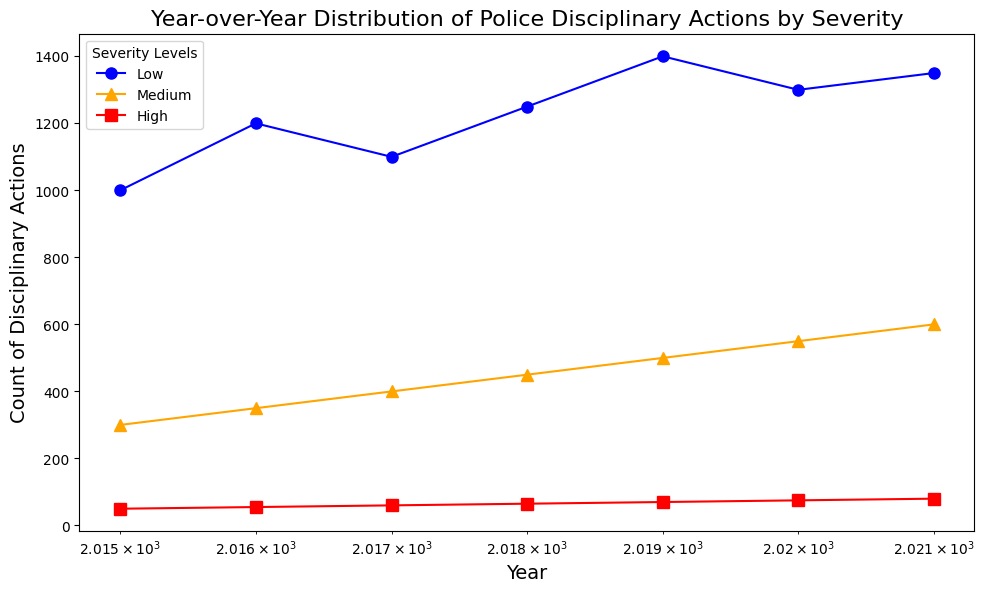How did the number of Low severity disciplinary actions change from 2015 to 2016? The count of Low severity disciplinary actions in 2015 was 1000 and increased to 1200 in 2016. The change is calculated as 1200 - 1000.
Answer: 200 Which year had the highest number of High severity disciplinary actions? By looking at the plot, the year 2021 had the highest count of High severity disciplinary actions with 80 incidents.
Answer: 2021 What is the average number of Medium severity disciplinary actions between 2015 and 2018? The counts for Medium severity from 2015 to 2018 are 300, 350, 400, and 450. The sum is 300 + 350 + 400 + 450 = 1500. The average is calculated as 1500 / 4.
Answer: 375 By how much did the total number of disciplinary actions in all severity levels change from 2019 to 2020? In 2019, the counts are 1400 (Low), 500 (Medium), and 70 (High), totaling 1970. In 2020, they are 1300 (Low), 550 (Medium), and 75 (High), totaling 1925. The change is 1970 - 1925.
Answer: -45 Which severity level had the most consistent increase year-over-year? By observing the plot, the Medium severity level shows a consistent increase from 300 in 2015 to 600 in 2021 without any year of decline.
Answer: Medium In which year did Low severity disciplinary actions peak? The plot indicates that the Low severity disciplinary actions peaked in 2019 with a count of 1400.
Answer: 2019 What is the difference in the number of High severity disciplinary actions between 2015 and 2021? In 2015, the number of High severity actions was 50, and in 2021, it was 80. The difference is 80 - 50.
Answer: 30 Compare the number of Medium severity actions in 2016 and 2019. Which year had more, and by how much? In 2016, there were 350 Medium severity actions, and in 2019, there were 500. 2019 had more by 500 - 350.
Answer: 2019 by 150 Calculating the increase rate of Low severity disciplinary actions from 2017 to 2018, what was the percentage increase? From 2017 to 2018, Low severity actions increased from 1100 to 1250. The percentage increase is ((1250 - 1100) / 1100) * 100.
Answer: 13.64% Between which two consecutive years was the increase in High severity disciplinary actions the greatest? Comparing the increases year-over-year: 2015-2016: 5, 2016-2017: 5, 2017-2018: 5, 2018-2019: 5, 2019-2020: 5, 2020-2021: 5. All increases are the same, 5.
Answer: Any consecutive years 